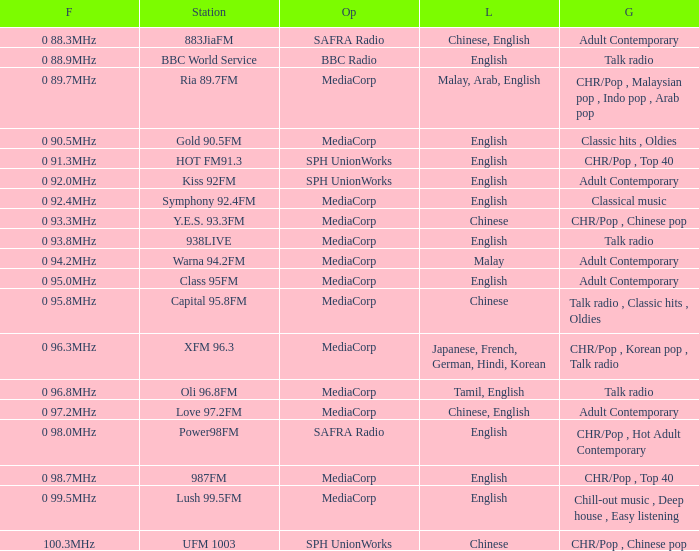What genre has a station of Class 95FM? Adult Contemporary. 